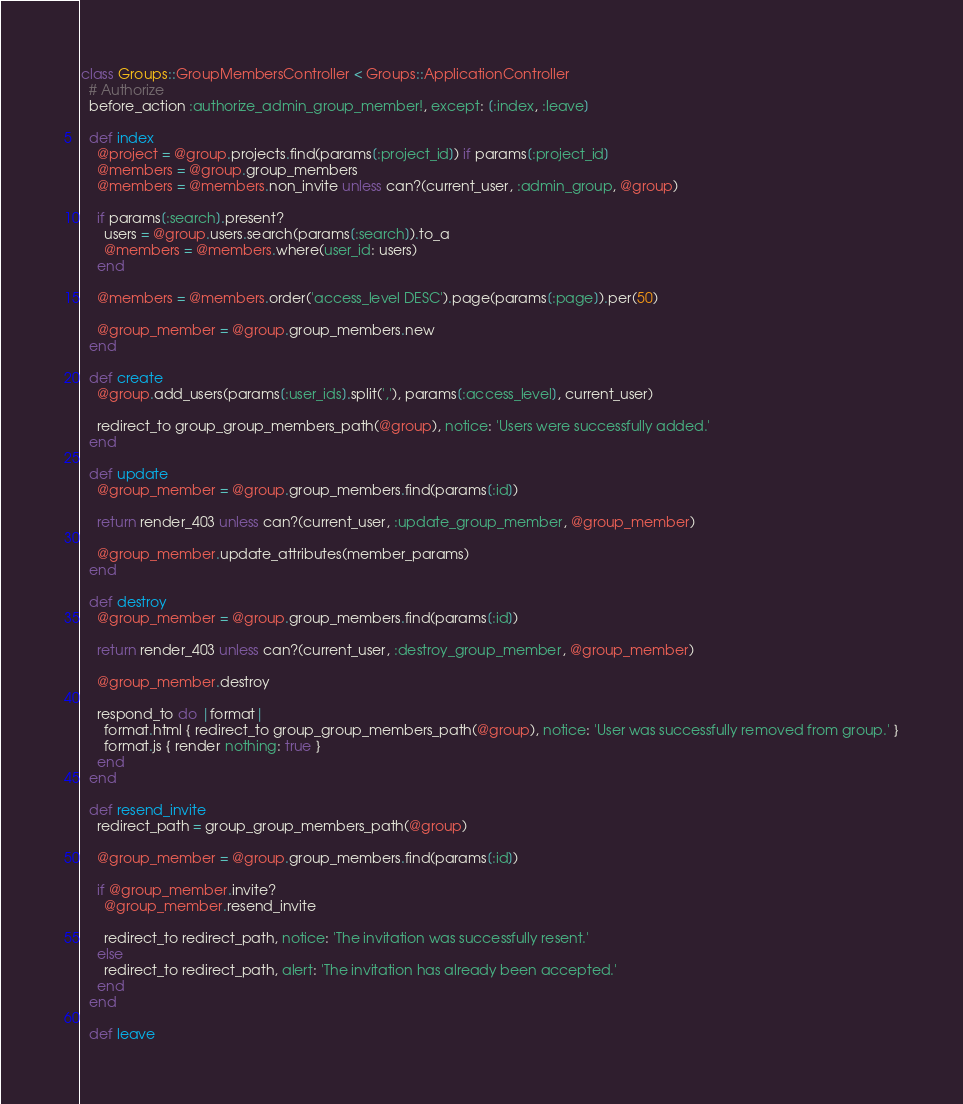Convert code to text. <code><loc_0><loc_0><loc_500><loc_500><_Ruby_>class Groups::GroupMembersController < Groups::ApplicationController
  # Authorize
  before_action :authorize_admin_group_member!, except: [:index, :leave]

  def index
    @project = @group.projects.find(params[:project_id]) if params[:project_id]
    @members = @group.group_members
    @members = @members.non_invite unless can?(current_user, :admin_group, @group)

    if params[:search].present?
      users = @group.users.search(params[:search]).to_a
      @members = @members.where(user_id: users)
    end

    @members = @members.order('access_level DESC').page(params[:page]).per(50)

    @group_member = @group.group_members.new
  end

  def create
    @group.add_users(params[:user_ids].split(','), params[:access_level], current_user)

    redirect_to group_group_members_path(@group), notice: 'Users were successfully added.'
  end

  def update
    @group_member = @group.group_members.find(params[:id])

    return render_403 unless can?(current_user, :update_group_member, @group_member)

    @group_member.update_attributes(member_params)
  end

  def destroy
    @group_member = @group.group_members.find(params[:id])

    return render_403 unless can?(current_user, :destroy_group_member, @group_member)

    @group_member.destroy

    respond_to do |format|
      format.html { redirect_to group_group_members_path(@group), notice: 'User was successfully removed from group.' }
      format.js { render nothing: true }
    end
  end

  def resend_invite
    redirect_path = group_group_members_path(@group)

    @group_member = @group.group_members.find(params[:id])

    if @group_member.invite?
      @group_member.resend_invite

      redirect_to redirect_path, notice: 'The invitation was successfully resent.'
    else
      redirect_to redirect_path, alert: 'The invitation has already been accepted.'
    end
  end

  def leave</code> 